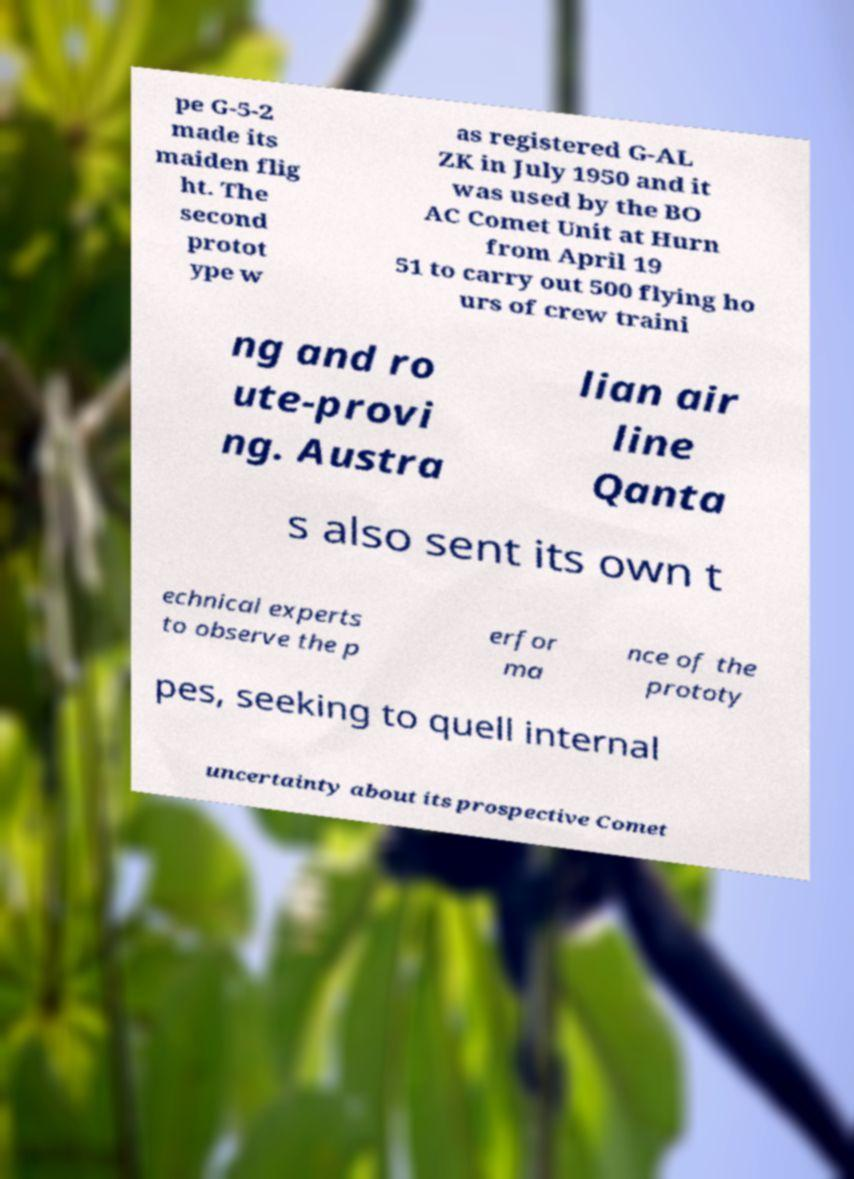I need the written content from this picture converted into text. Can you do that? pe G-5-2 made its maiden flig ht. The second protot ype w as registered G-AL ZK in July 1950 and it was used by the BO AC Comet Unit at Hurn from April 19 51 to carry out 500 flying ho urs of crew traini ng and ro ute-provi ng. Austra lian air line Qanta s also sent its own t echnical experts to observe the p erfor ma nce of the prototy pes, seeking to quell internal uncertainty about its prospective Comet 